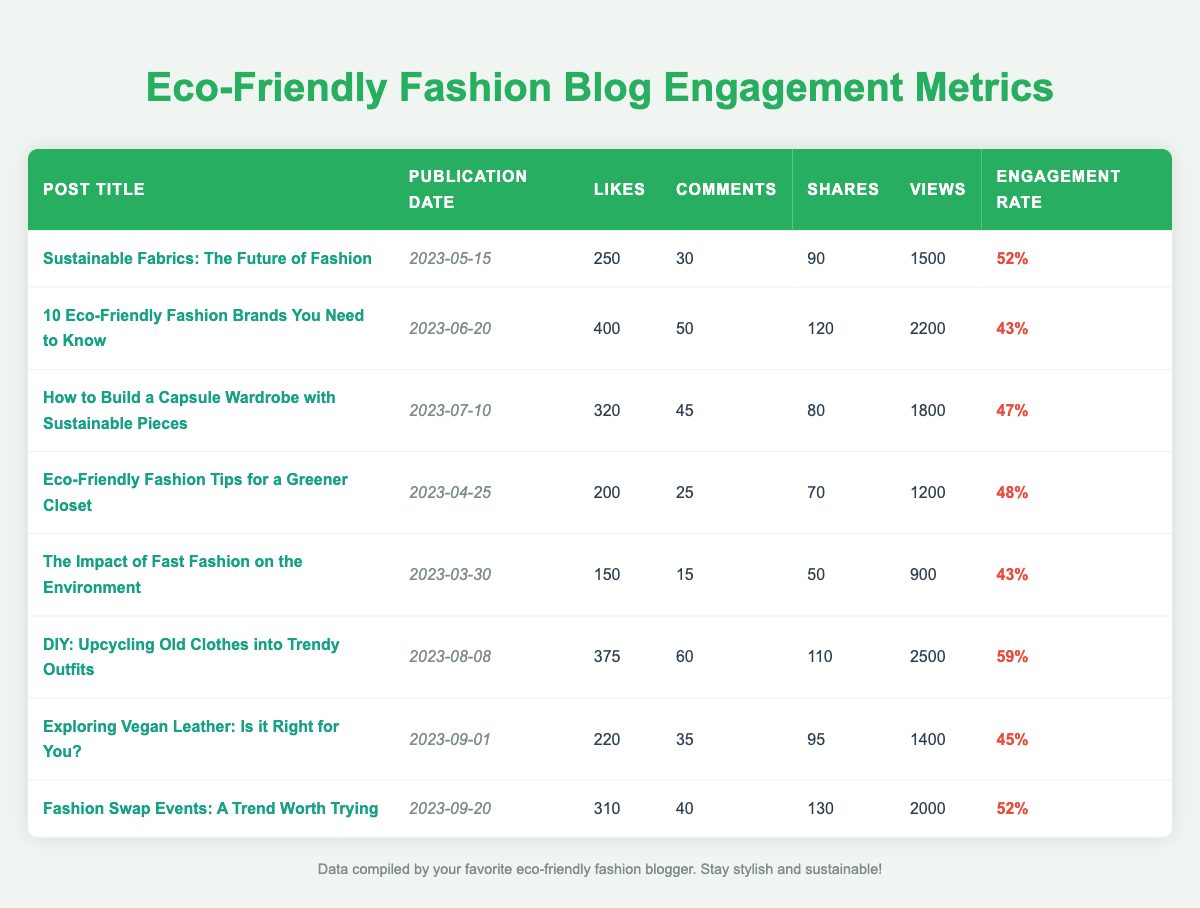What is the post with the highest number of likes? The table shows each post's number of likes. The post titled "10 Eco-Friendly Fashion Brands You Need to Know" has the highest number of likes at 400.
Answer: 10 Eco-Friendly Fashion Brands You Need to Know Which post has the lowest engagement rate? The engagement rate can be directly viewed in the table. The post titled "The Impact of Fast Fashion on the Environment" has the lowest engagement rate at 43%.
Answer: The Impact of Fast Fashion on the Environment What is the total number of shares across all blog posts? To find the total shares, sum the individual shares: 90 + 120 + 80 + 70 + 50 + 110 + 95 + 130 = 855.
Answer: 855 On which date was the post titled "DIY: Upcycling Old Clothes into Trendy Outfits" published? The publication date for this post is listed in the table, showing it was published on August 8, 2023.
Answer: 2023-08-08 How many posts have an engagement rate greater than 50%? By examining the engagement rates, we find that two posts have rates greater than 50%: "DIY: Upcycling Old Clothes into Trendy Outfits" (59%) and "Sustainable Fabrics: The Future of Fashion" (52%).
Answer: 2 What is the average number of comments on all blog posts? To find the average, first sum the comments: 30 + 50 + 45 + 25 + 15 + 60 + 35 + 40 = 355. There are 8 posts, so the average is 355/8 = 44.375, which rounds to 44 (when considering whole numbers).
Answer: 44 Is "Eco-Friendly Fashion Tips for a Greener Closet" more liked than "Exploring Vegan Leather: Is it Right for You?"? The likes are compared directly: "Eco-Friendly Fashion Tips for a Greener Closet" has 200 likes, while "Exploring Vegan Leather: Is it Right for You?" has 220 likes, so the statement is false.
Answer: No What is the difference in the number of views between the post with the highest views and the lowest views? The highest views are for "DIY: Upcycling Old Clothes into Trendy Outfits" with 2500 views, and the lowest views are for "The Impact of Fast Fashion on the Environment" with 900 views. The difference is 2500 - 900 = 1600.
Answer: 1600 